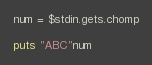<code> <loc_0><loc_0><loc_500><loc_500><_Ruby_>num = $stdin.gets.chomp

puts "ABC"num</code> 